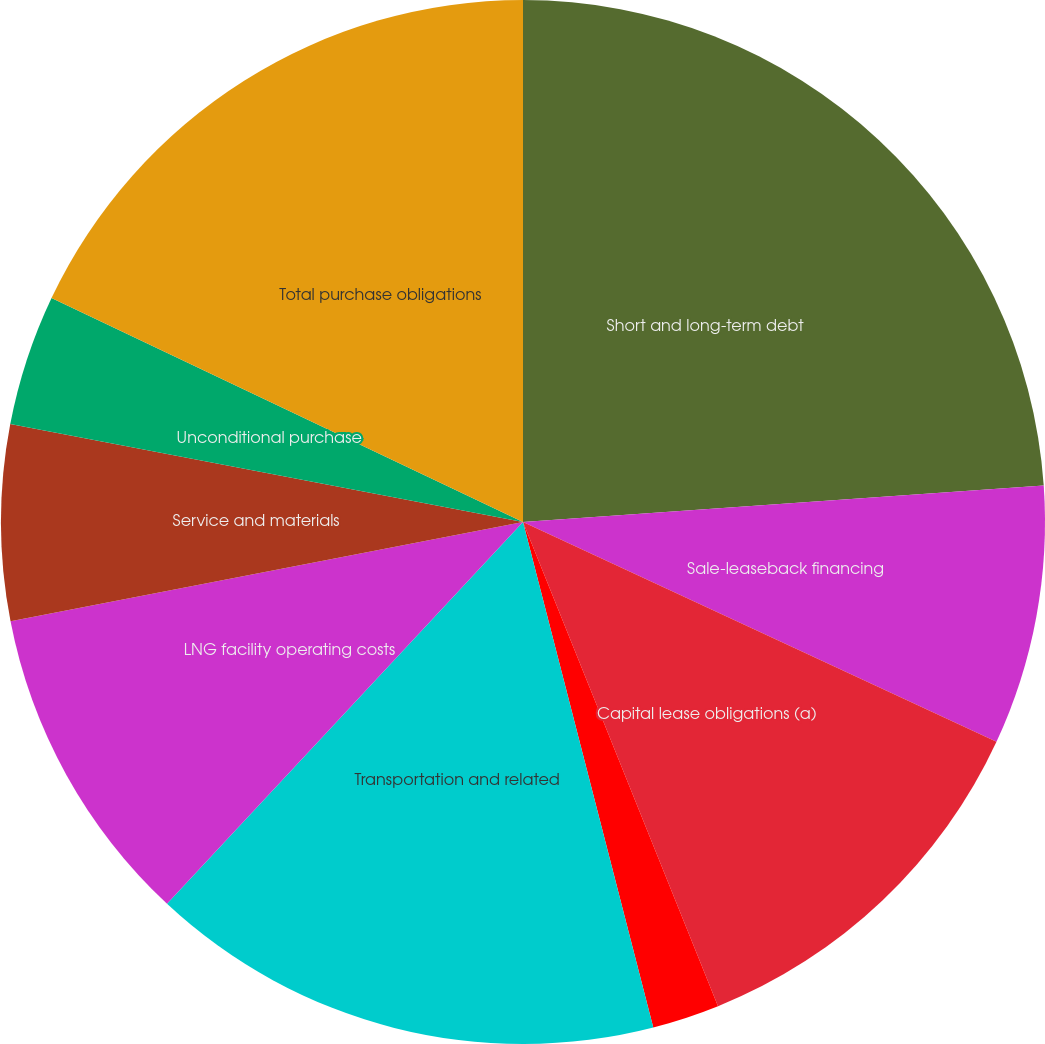Convert chart. <chart><loc_0><loc_0><loc_500><loc_500><pie_chart><fcel>Short and long-term debt<fcel>Sale-leaseback financing<fcel>Capital lease obligations (a)<fcel>Operating lease obligations<fcel>Transportation and related<fcel>LNG facility operating costs<fcel>Service and materials<fcel>Unconditional purchase<fcel>Total purchase obligations<nl><fcel>23.89%<fcel>8.03%<fcel>11.99%<fcel>2.08%<fcel>15.96%<fcel>10.01%<fcel>6.05%<fcel>4.06%<fcel>17.94%<nl></chart> 